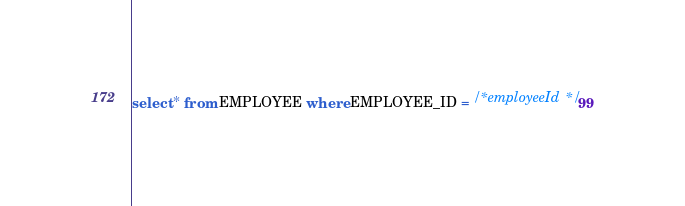<code> <loc_0><loc_0><loc_500><loc_500><_SQL_>select * from EMPLOYEE where EMPLOYEE_ID = /* employeeId */99
</code> 